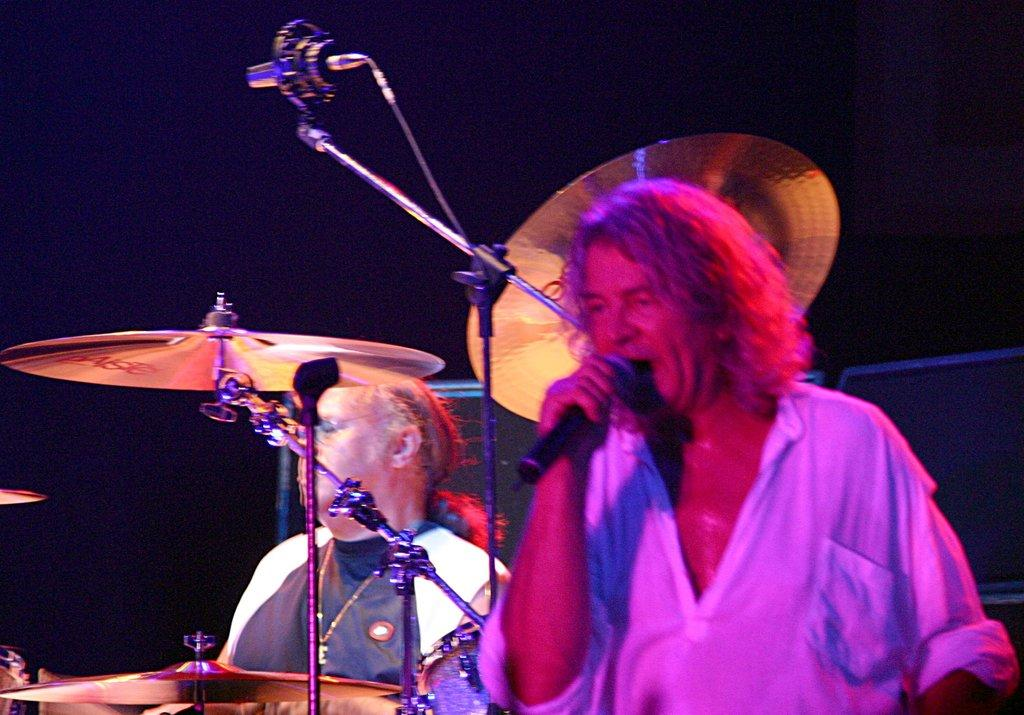What are the persons in the image doing? The persons in the image are holding a mic. What else can be seen in the image besides the persons holding the mic? There are musical instruments and an object that looks like a speaker in the image. Can you tell me what time it is in the image? There is no clock or any indication of time in the image, so it is not possible to determine the hour. 